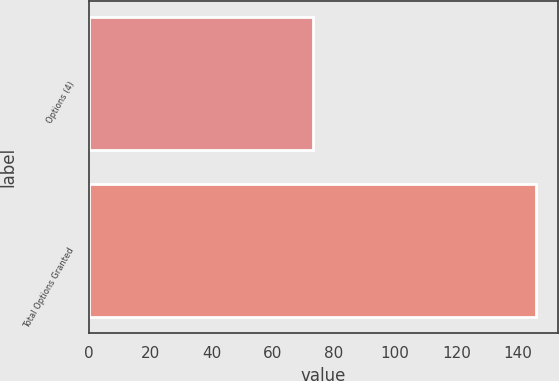Convert chart to OTSL. <chart><loc_0><loc_0><loc_500><loc_500><bar_chart><fcel>Options (4)<fcel>Total Options Granted<nl><fcel>73<fcel>146<nl></chart> 